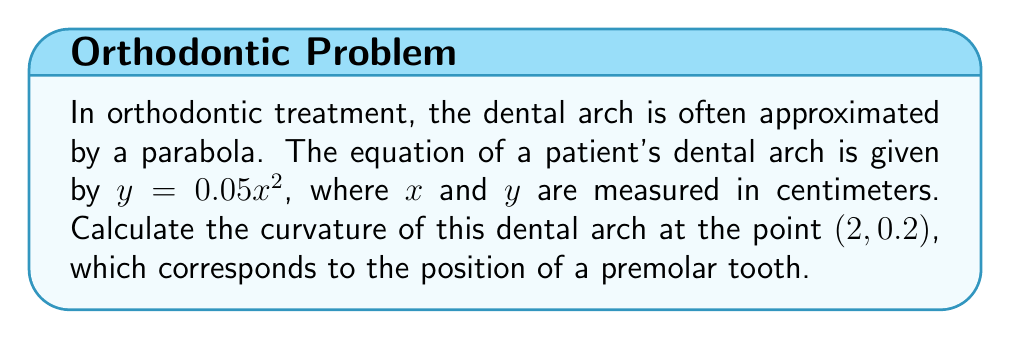Provide a solution to this math problem. To calculate the curvature of the dental arch, we'll follow these steps:

1) The general formula for curvature $K$ at a point $(x, y)$ on a curve $y = f(x)$ is:

   $$K = \frac{|f''(x)|}{(1 + [f'(x)]^2)^{3/2}}$$

2) First, let's find $f'(x)$ and $f''(x)$:
   
   $f(x) = 0.05x^2$
   $f'(x) = 0.1x$
   $f''(x) = 0.1$

3) Now, let's evaluate $f'(x)$ at $x = 2$:
   
   $f'(2) = 0.1(2) = 0.2$

4) We can now substitute these values into the curvature formula:

   $$K = \frac{|0.1|}{(1 + [0.2]^2)^{3/2}}$$

5) Simplify:
   
   $$K = \frac{0.1}{(1 + 0.04)^{3/2}} = \frac{0.1}{(1.04)^{3/2}}$$

6) Calculate:
   
   $$K \approx 0.0962 \text{ cm}^{-1}$$

This value represents the curvature of the dental arch at the position of the premolar tooth.
Answer: $0.0962 \text{ cm}^{-1}$ 